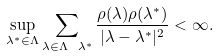<formula> <loc_0><loc_0><loc_500><loc_500>\sup _ { \lambda ^ { * } \in \Lambda } \sum _ { \lambda \in \Lambda \ \lambda ^ { * } } \frac { \rho ( \lambda ) \rho ( \lambda ^ { * } ) } { | \lambda - \lambda ^ { * } | ^ { 2 } } < \infty .</formula> 